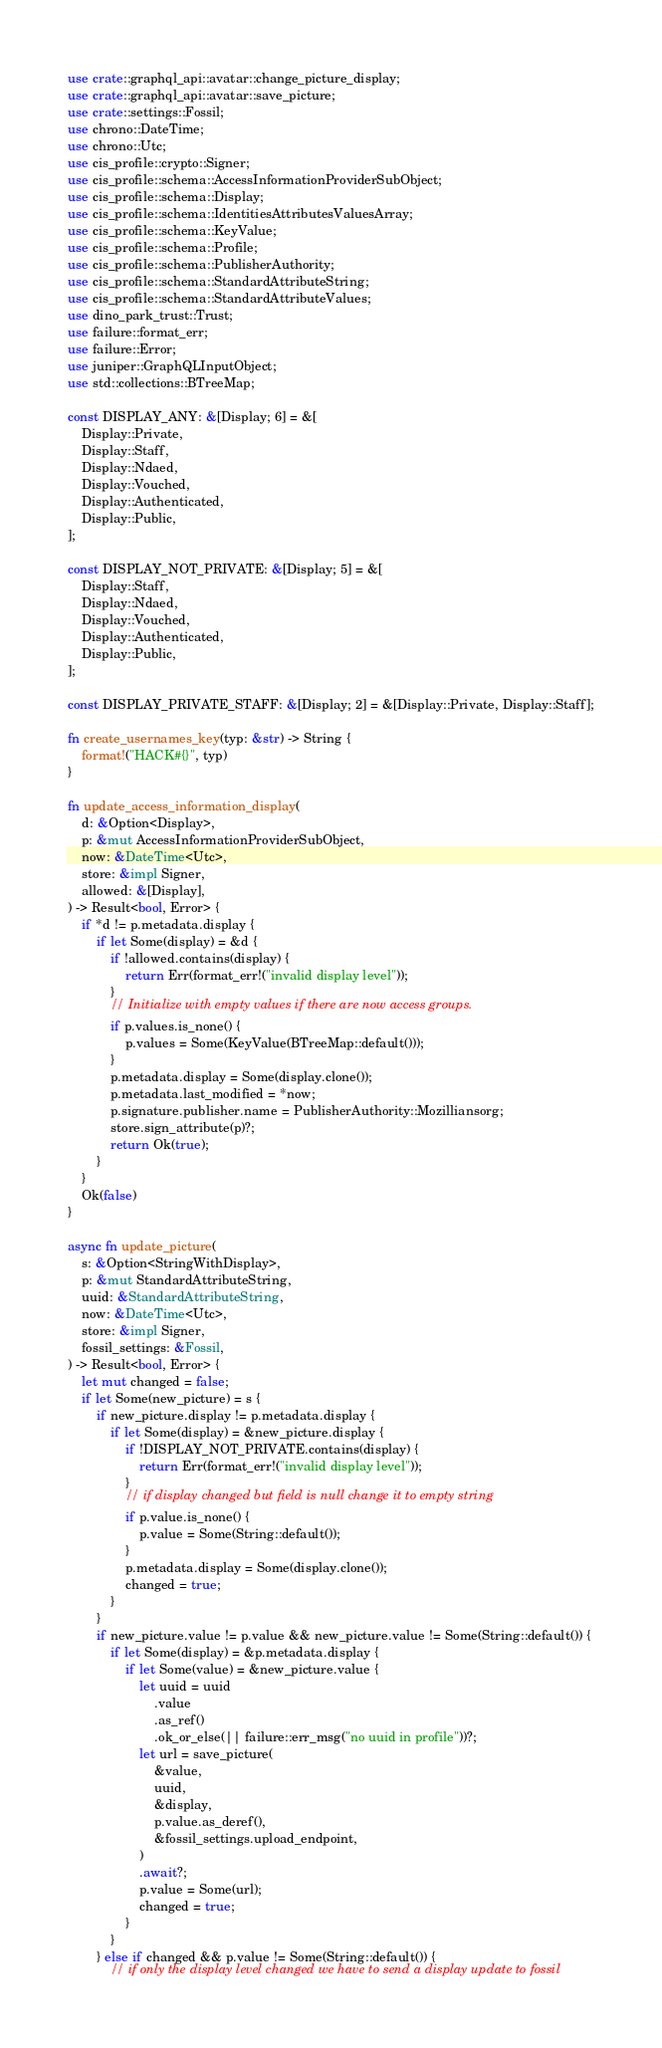Convert code to text. <code><loc_0><loc_0><loc_500><loc_500><_Rust_>use crate::graphql_api::avatar::change_picture_display;
use crate::graphql_api::avatar::save_picture;
use crate::settings::Fossil;
use chrono::DateTime;
use chrono::Utc;
use cis_profile::crypto::Signer;
use cis_profile::schema::AccessInformationProviderSubObject;
use cis_profile::schema::Display;
use cis_profile::schema::IdentitiesAttributesValuesArray;
use cis_profile::schema::KeyValue;
use cis_profile::schema::Profile;
use cis_profile::schema::PublisherAuthority;
use cis_profile::schema::StandardAttributeString;
use cis_profile::schema::StandardAttributeValues;
use dino_park_trust::Trust;
use failure::format_err;
use failure::Error;
use juniper::GraphQLInputObject;
use std::collections::BTreeMap;

const DISPLAY_ANY: &[Display; 6] = &[
    Display::Private,
    Display::Staff,
    Display::Ndaed,
    Display::Vouched,
    Display::Authenticated,
    Display::Public,
];

const DISPLAY_NOT_PRIVATE: &[Display; 5] = &[
    Display::Staff,
    Display::Ndaed,
    Display::Vouched,
    Display::Authenticated,
    Display::Public,
];

const DISPLAY_PRIVATE_STAFF: &[Display; 2] = &[Display::Private, Display::Staff];

fn create_usernames_key(typ: &str) -> String {
    format!("HACK#{}", typ)
}

fn update_access_information_display(
    d: &Option<Display>,
    p: &mut AccessInformationProviderSubObject,
    now: &DateTime<Utc>,
    store: &impl Signer,
    allowed: &[Display],
) -> Result<bool, Error> {
    if *d != p.metadata.display {
        if let Some(display) = &d {
            if !allowed.contains(display) {
                return Err(format_err!("invalid display level"));
            }
            // Initialize with empty values if there are now access groups.
            if p.values.is_none() {
                p.values = Some(KeyValue(BTreeMap::default()));
            }
            p.metadata.display = Some(display.clone());
            p.metadata.last_modified = *now;
            p.signature.publisher.name = PublisherAuthority::Mozilliansorg;
            store.sign_attribute(p)?;
            return Ok(true);
        }
    }
    Ok(false)
}

async fn update_picture(
    s: &Option<StringWithDisplay>,
    p: &mut StandardAttributeString,
    uuid: &StandardAttributeString,
    now: &DateTime<Utc>,
    store: &impl Signer,
    fossil_settings: &Fossil,
) -> Result<bool, Error> {
    let mut changed = false;
    if let Some(new_picture) = s {
        if new_picture.display != p.metadata.display {
            if let Some(display) = &new_picture.display {
                if !DISPLAY_NOT_PRIVATE.contains(display) {
                    return Err(format_err!("invalid display level"));
                }
                // if display changed but field is null change it to empty string
                if p.value.is_none() {
                    p.value = Some(String::default());
                }
                p.metadata.display = Some(display.clone());
                changed = true;
            }
        }
        if new_picture.value != p.value && new_picture.value != Some(String::default()) {
            if let Some(display) = &p.metadata.display {
                if let Some(value) = &new_picture.value {
                    let uuid = uuid
                        .value
                        .as_ref()
                        .ok_or_else(|| failure::err_msg("no uuid in profile"))?;
                    let url = save_picture(
                        &value,
                        uuid,
                        &display,
                        p.value.as_deref(),
                        &fossil_settings.upload_endpoint,
                    )
                    .await?;
                    p.value = Some(url);
                    changed = true;
                }
            }
        } else if changed && p.value != Some(String::default()) {
            // if only the display level changed we have to send a display update to fossil</code> 